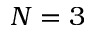<formula> <loc_0><loc_0><loc_500><loc_500>N = 3</formula> 